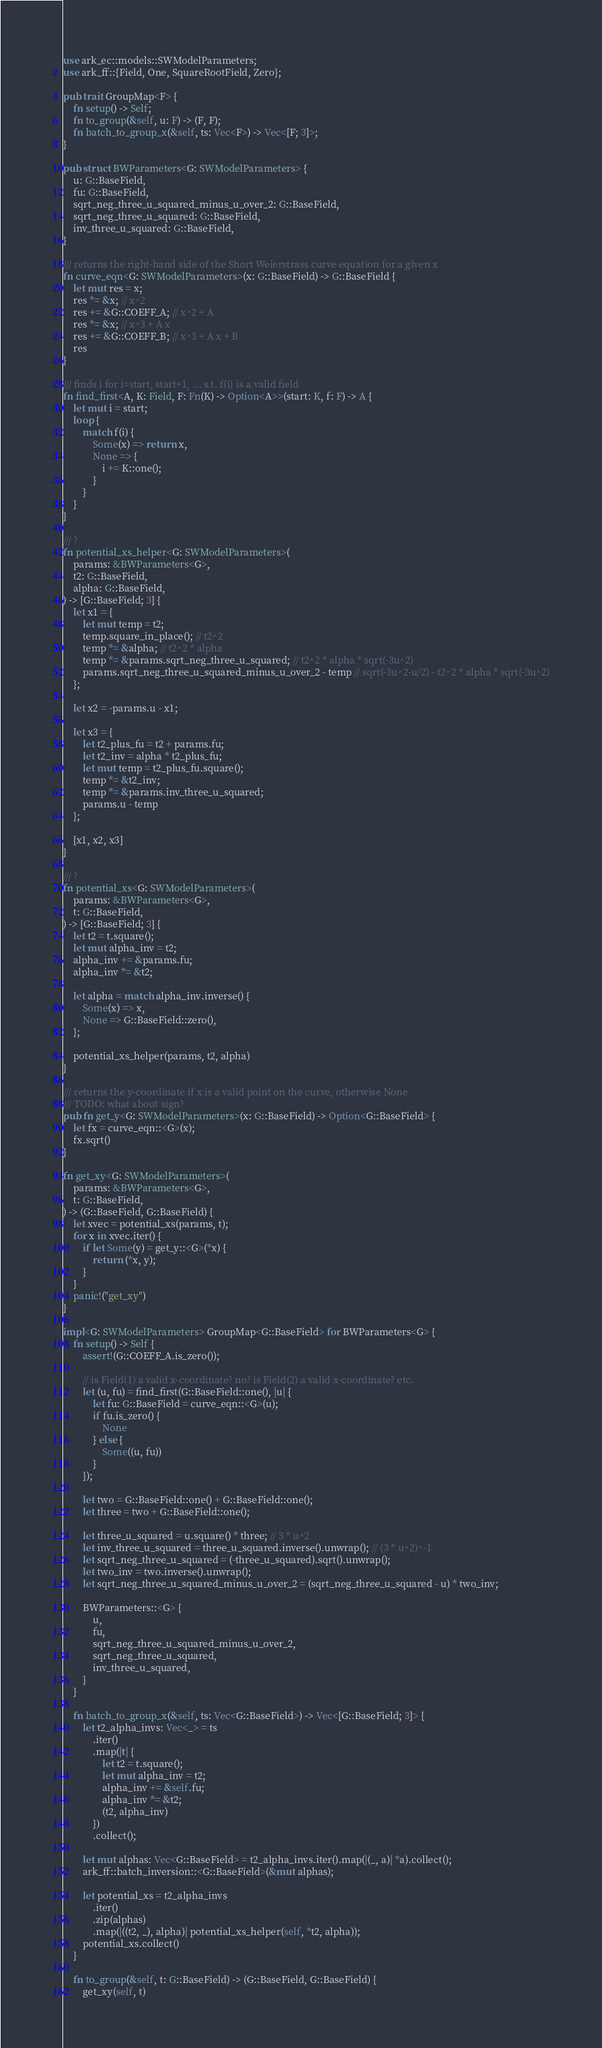Convert code to text. <code><loc_0><loc_0><loc_500><loc_500><_Rust_>use ark_ec::models::SWModelParameters;
use ark_ff::{Field, One, SquareRootField, Zero};

pub trait GroupMap<F> {
    fn setup() -> Self;
    fn to_group(&self, u: F) -> (F, F);
    fn batch_to_group_x(&self, ts: Vec<F>) -> Vec<[F; 3]>;
}

pub struct BWParameters<G: SWModelParameters> {
    u: G::BaseField,
    fu: G::BaseField,
    sqrt_neg_three_u_squared_minus_u_over_2: G::BaseField,
    sqrt_neg_three_u_squared: G::BaseField,
    inv_three_u_squared: G::BaseField,
}

/// returns the right-hand side of the Short Weierstrass curve equation for a given x
fn curve_eqn<G: SWModelParameters>(x: G::BaseField) -> G::BaseField {
    let mut res = x;
    res *= &x; // x^2
    res += &G::COEFF_A; // x^2 + A
    res *= &x; // x^3 + A x
    res += &G::COEFF_B; // x^3 + A x + B
    res
}

/// finds i for i=start, start+1, ... s.t. f(i) is a valid field
fn find_first<A, K: Field, F: Fn(K) -> Option<A>>(start: K, f: F) -> A {
    let mut i = start;
    loop {
        match f(i) {
            Some(x) => return x,
            None => {
                i += K::one();
            }
        }
    }
}

/// ?
fn potential_xs_helper<G: SWModelParameters>(
    params: &BWParameters<G>,
    t2: G::BaseField,
    alpha: G::BaseField,
) -> [G::BaseField; 3] {
    let x1 = {
        let mut temp = t2;
        temp.square_in_place(); // t2^2
        temp *= &alpha; // t2^2 * alpha
        temp *= &params.sqrt_neg_three_u_squared; // t2^2 * alpha * sqrt(-3u^2)
        params.sqrt_neg_three_u_squared_minus_u_over_2 - temp // sqrt(-3u^2-u/2) - t2^2 * alpha * sqrt(-3u^2)
    };

    let x2 = -params.u - x1;

    let x3 = {
        let t2_plus_fu = t2 + params.fu;
        let t2_inv = alpha * t2_plus_fu;
        let mut temp = t2_plus_fu.square();
        temp *= &t2_inv;
        temp *= &params.inv_three_u_squared;
        params.u - temp
    };

    [x1, x2, x3]
}

/// ?
fn potential_xs<G: SWModelParameters>(
    params: &BWParameters<G>,
    t: G::BaseField,
) -> [G::BaseField; 3] {
    let t2 = t.square();
    let mut alpha_inv = t2;
    alpha_inv += &params.fu;
    alpha_inv *= &t2;

    let alpha = match alpha_inv.inverse() {
        Some(x) => x,
        None => G::BaseField::zero(),
    };

    potential_xs_helper(params, t2, alpha)
}

/// returns the y-coordinate if x is a valid point on the curve, otherwise None
/// TODO: what about sign?
pub fn get_y<G: SWModelParameters>(x: G::BaseField) -> Option<G::BaseField> {
    let fx = curve_eqn::<G>(x);
    fx.sqrt()
}

fn get_xy<G: SWModelParameters>(
    params: &BWParameters<G>,
    t: G::BaseField,
) -> (G::BaseField, G::BaseField) {
    let xvec = potential_xs(params, t);
    for x in xvec.iter() {
        if let Some(y) = get_y::<G>(*x) {
            return (*x, y);
        }
    }
    panic!("get_xy")
}

impl<G: SWModelParameters> GroupMap<G::BaseField> for BWParameters<G> {
    fn setup() -> Self {
        assert!(G::COEFF_A.is_zero());

        // is Field(1) a valid x-coordinate? no? is Field(2) a valid x-coordinate? etc.
        let (u, fu) = find_first(G::BaseField::one(), |u| {
            let fu: G::BaseField = curve_eqn::<G>(u);
            if fu.is_zero() {
                None
            } else {
                Some((u, fu))
            }
        });

        let two = G::BaseField::one() + G::BaseField::one();
        let three = two + G::BaseField::one();

        let three_u_squared = u.square() * three; // 3 * u^2
        let inv_three_u_squared = three_u_squared.inverse().unwrap(); // (3 * u^2)^-1
        let sqrt_neg_three_u_squared = (-three_u_squared).sqrt().unwrap();
        let two_inv = two.inverse().unwrap();
        let sqrt_neg_three_u_squared_minus_u_over_2 = (sqrt_neg_three_u_squared - u) * two_inv;

        BWParameters::<G> {
            u,
            fu,
            sqrt_neg_three_u_squared_minus_u_over_2,
            sqrt_neg_three_u_squared,
            inv_three_u_squared,
        }
    }

    fn batch_to_group_x(&self, ts: Vec<G::BaseField>) -> Vec<[G::BaseField; 3]> {
        let t2_alpha_invs: Vec<_> = ts
            .iter()
            .map(|t| {
                let t2 = t.square();
                let mut alpha_inv = t2;
                alpha_inv += &self.fu;
                alpha_inv *= &t2;
                (t2, alpha_inv)
            })
            .collect();

        let mut alphas: Vec<G::BaseField> = t2_alpha_invs.iter().map(|(_, a)| *a).collect();
        ark_ff::batch_inversion::<G::BaseField>(&mut alphas);

        let potential_xs = t2_alpha_invs
            .iter()
            .zip(alphas)
            .map(|((t2, _), alpha)| potential_xs_helper(self, *t2, alpha));
        potential_xs.collect()
    }

    fn to_group(&self, t: G::BaseField) -> (G::BaseField, G::BaseField) {
        get_xy(self, t)</code> 